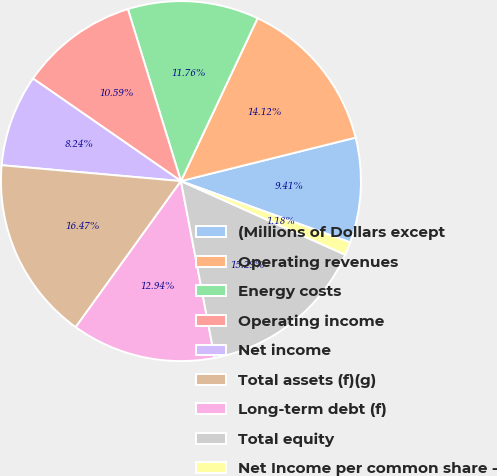Convert chart to OTSL. <chart><loc_0><loc_0><loc_500><loc_500><pie_chart><fcel>(Millions of Dollars except<fcel>Operating revenues<fcel>Energy costs<fcel>Operating income<fcel>Net income<fcel>Total assets (f)(g)<fcel>Long-term debt (f)<fcel>Total equity<fcel>Net Income per common share -<nl><fcel>9.41%<fcel>14.12%<fcel>11.76%<fcel>10.59%<fcel>8.24%<fcel>16.47%<fcel>12.94%<fcel>15.29%<fcel>1.18%<nl></chart> 